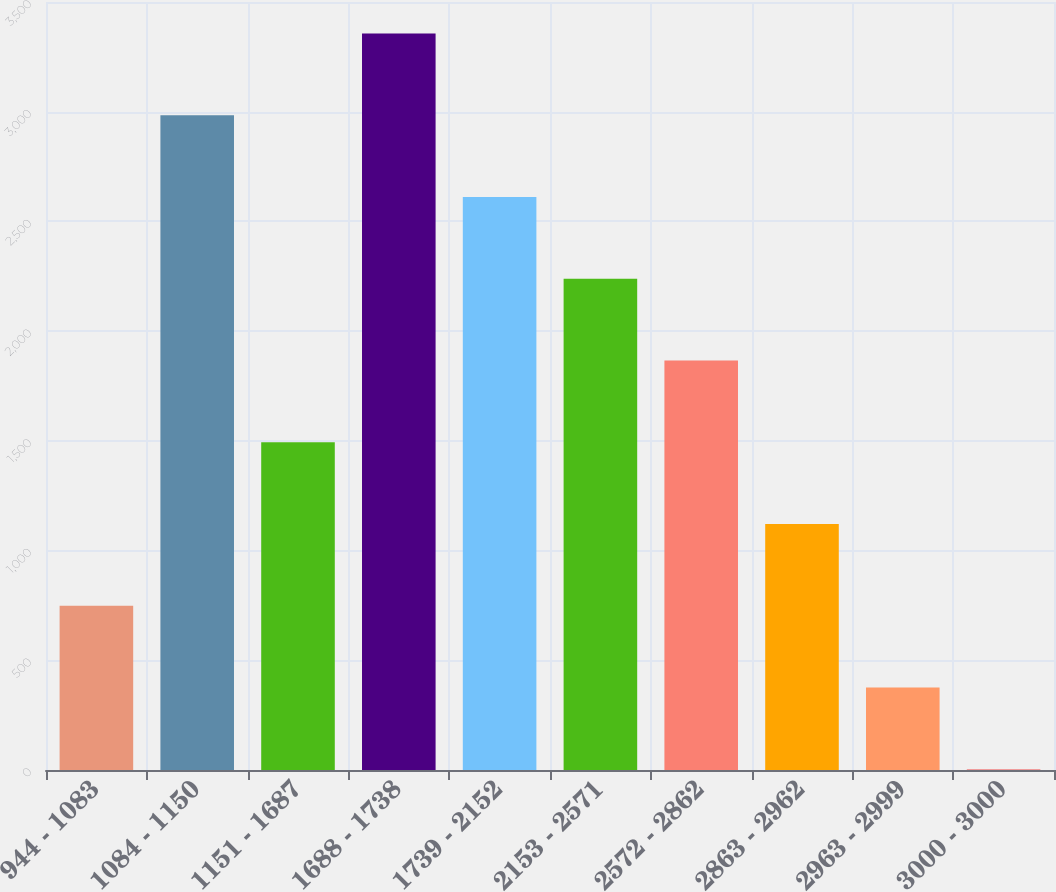Convert chart to OTSL. <chart><loc_0><loc_0><loc_500><loc_500><bar_chart><fcel>944 - 1083<fcel>1084 - 1150<fcel>1151 - 1687<fcel>1688 - 1738<fcel>1739 - 2152<fcel>2153 - 2571<fcel>2572 - 2862<fcel>2863 - 2962<fcel>2963 - 2999<fcel>3000 - 3000<nl><fcel>748.2<fcel>2983.8<fcel>1493.4<fcel>3356.4<fcel>2611.2<fcel>2238.6<fcel>1866<fcel>1120.8<fcel>375.6<fcel>3<nl></chart> 